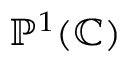<formula> <loc_0><loc_0><loc_500><loc_500>\mathbb { P } ^ { 1 } ( \mathbb { C } )</formula> 